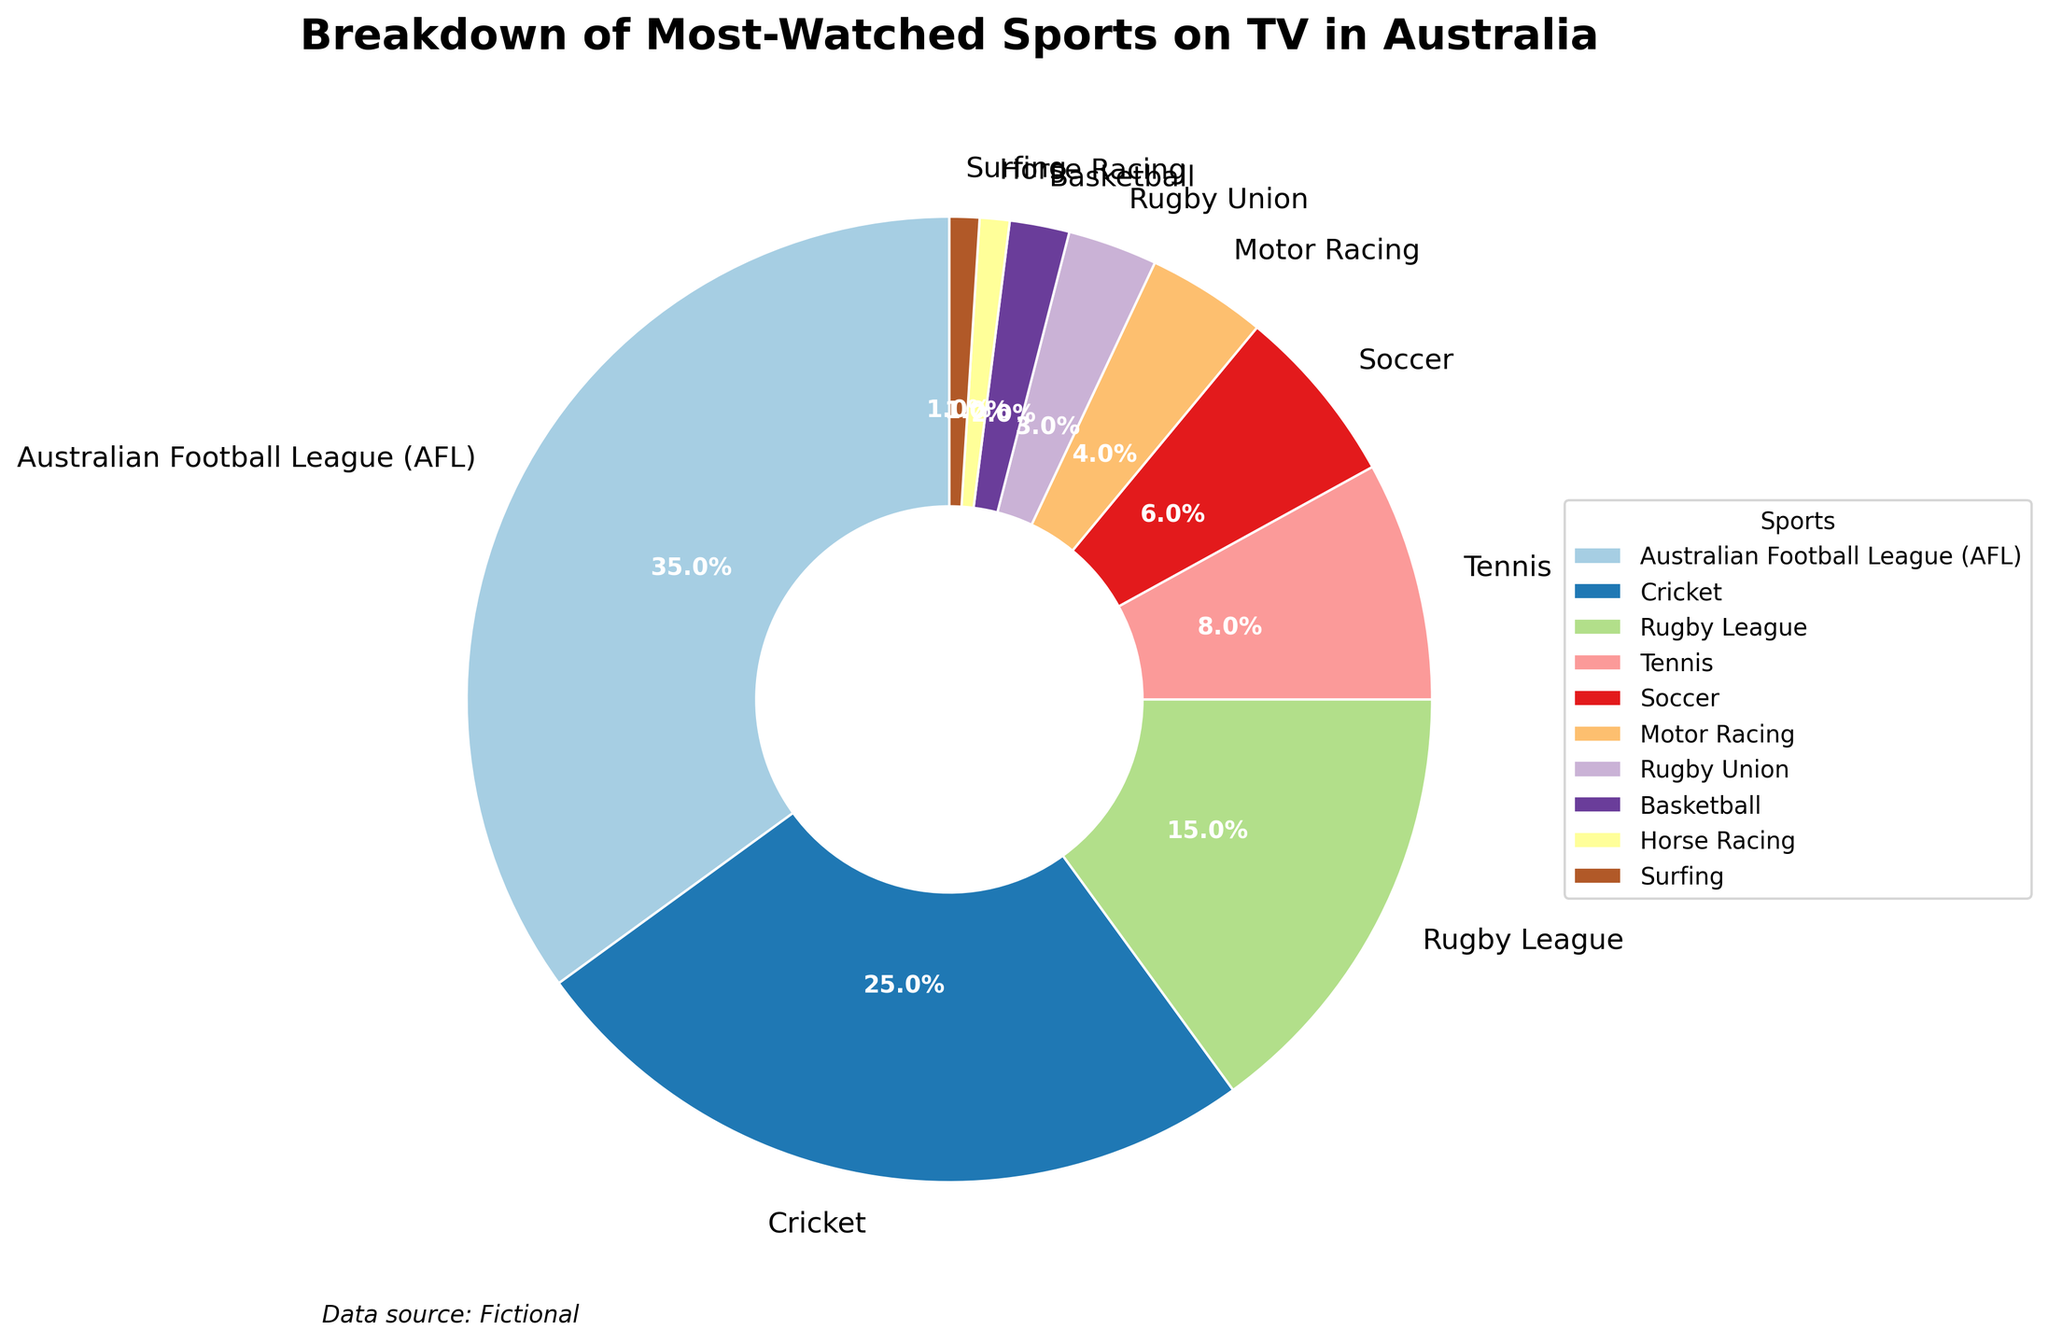Which sport holds the largest share of TV viewership in Australia? The pie chart shows the largest segment being the Australian Football League (AFL) with a percentage of 35%.
Answer: Australian Football League (AFL) What is the difference in percentage share between Cricket and Rugby League? The pie chart shows Cricket with a 25% share and Rugby League with a 15% share. The difference is 25% - 15% = 10%.
Answer: 10% Which sports have the smallest and largest slices in the pie chart? The smallest slices are Horse Racing and Surfing, each with 1%, and the largest slice is Australian Football League (AFL) with 35%.
Answer: Horse Racing and Surfing (smallest), Australian Football League (largest) How much of the total viewership is accounted for by Tennis and Soccer combined? Tennis has an 8% share and Soccer has a 6% share. Combined, they account for 8% + 6% = 14% of the total viewership.
Answer: 14% Which sport has a viewership percentage that is less than half of Soccer's percentage? Soccer has a 6% share. The sports with less than 3% (half of 6%) are Rugby Union with 3%, Basketball with 2%, Horse Racing with 1%, and Surfing with 1%.
Answer: Basketball, Horse Racing, Surfing How many sports have a viewership percentage greater than 10%? The pie chart shows Australian Football League (35%), Cricket (25%), and Rugby League (15%) with viewership percentages above 10%.
Answer: 3 What percentage of total viewership is represented by Motor Racing and Rugby Union together? Motor Racing has a 4% share, and Rugby Union has a 3% share. Together, they represent 4% + 3% = 7% of total viewership.
Answer: 7% Is the viewership percentage of Basketball greater than, less than, or equal to that of Horse Racing? Basketball has a 2% share while Horse Racing has a 1% share. Thus, Basketball's viewership is greater.
Answer: Greater Name the sports that make up less than 10% of the viewership individually. The sports with less than 10% viewership each are Tennis (8%), Soccer (6%), Motor Racing (4%), Rugby Union (3%), Basketball (2%), Horse Racing (1%), and Surfing (1%).
Answer: Tennis, Soccer, Motor Racing, Rugby Union, Basketball, Horse Racing, Surfing Which two sports collectively make up the same percentage as Cricke's share? Cricket has a 25% share. Australian Football League (35%) and Rugby League (15%) combined make 35% + 15% = 50%. The two sports Rugby League (15%) and Tennis (8%) collectively make 15% + 8% = 23%, which is close but not exact. There is no exact pair that makes 25%.
Answer: None 